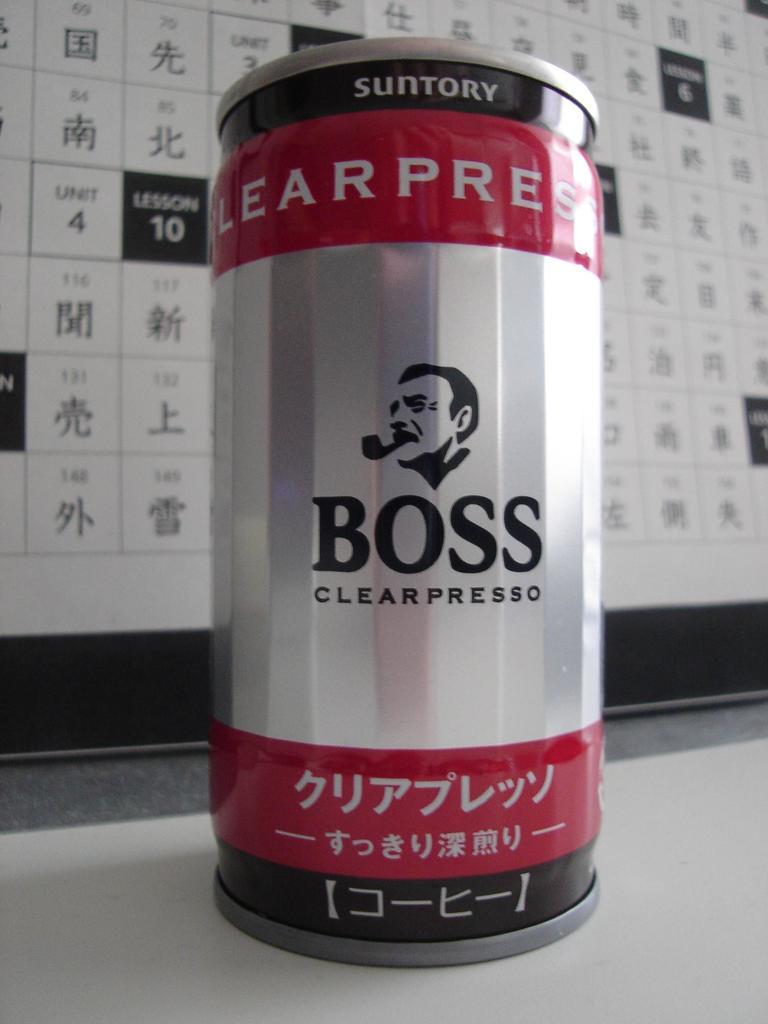What is this brand?
Your answer should be compact. Boss. 